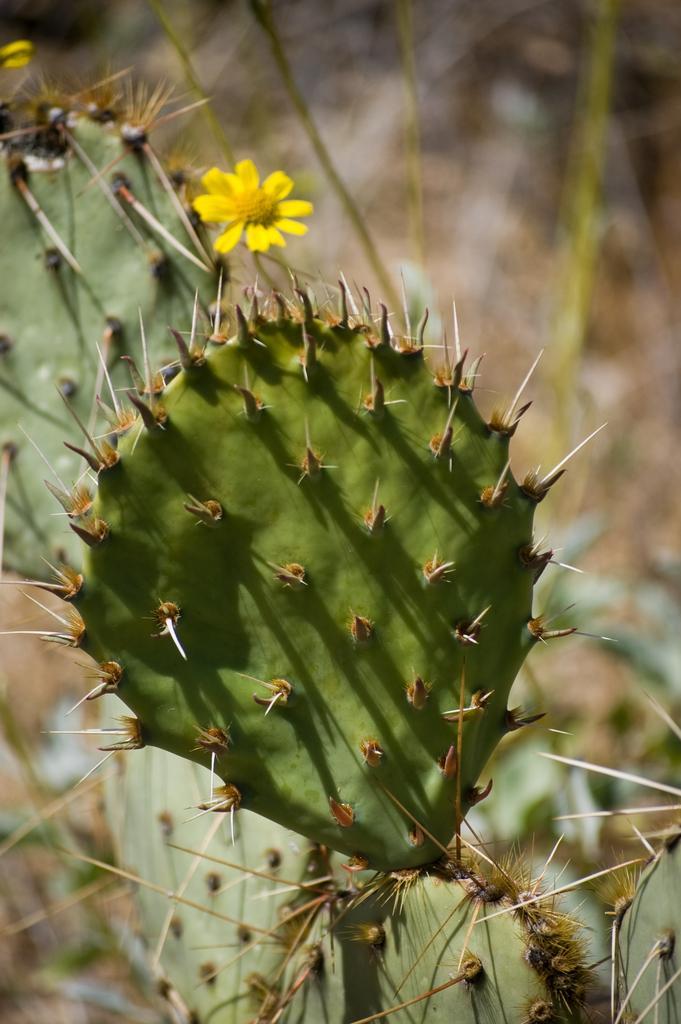How would you summarize this image in a sentence or two? In this image there is cactus. Here there is a yellow flower. The background is blurry. 